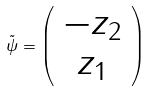<formula> <loc_0><loc_0><loc_500><loc_500>\tilde { \psi } = \left ( \begin{array} { c } - z _ { 2 } \\ z _ { 1 } \end{array} \right )</formula> 